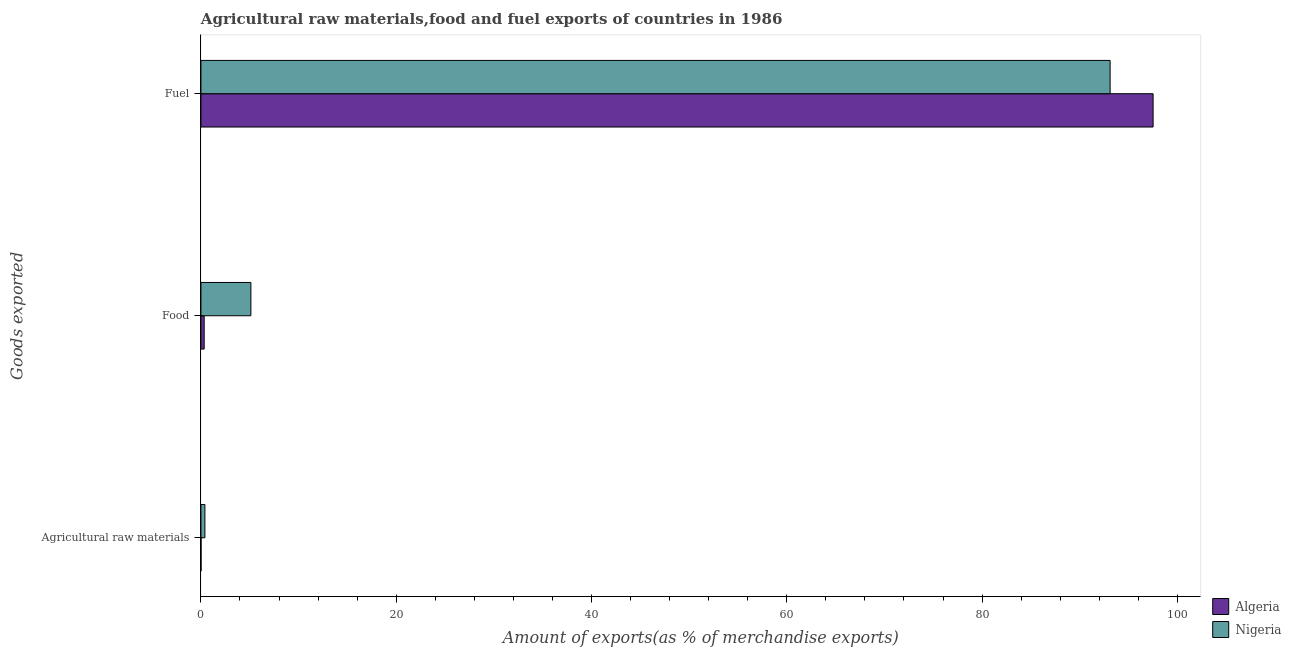How many groups of bars are there?
Provide a succinct answer. 3. Are the number of bars on each tick of the Y-axis equal?
Keep it short and to the point. Yes. What is the label of the 2nd group of bars from the top?
Offer a very short reply. Food. What is the percentage of fuel exports in Algeria?
Give a very brief answer. 97.51. Across all countries, what is the maximum percentage of food exports?
Provide a short and direct response. 5.12. Across all countries, what is the minimum percentage of food exports?
Give a very brief answer. 0.34. In which country was the percentage of raw materials exports maximum?
Your answer should be compact. Nigeria. In which country was the percentage of raw materials exports minimum?
Provide a short and direct response. Algeria. What is the total percentage of raw materials exports in the graph?
Ensure brevity in your answer.  0.42. What is the difference between the percentage of food exports in Algeria and that in Nigeria?
Keep it short and to the point. -4.78. What is the difference between the percentage of fuel exports in Nigeria and the percentage of food exports in Algeria?
Your answer should be compact. 92.78. What is the average percentage of fuel exports per country?
Ensure brevity in your answer.  95.31. What is the difference between the percentage of raw materials exports and percentage of fuel exports in Algeria?
Give a very brief answer. -97.5. What is the ratio of the percentage of raw materials exports in Algeria to that in Nigeria?
Your answer should be very brief. 0.03. Is the percentage of fuel exports in Algeria less than that in Nigeria?
Give a very brief answer. No. Is the difference between the percentage of fuel exports in Algeria and Nigeria greater than the difference between the percentage of food exports in Algeria and Nigeria?
Offer a terse response. Yes. What is the difference between the highest and the second highest percentage of fuel exports?
Offer a very short reply. 4.4. What is the difference between the highest and the lowest percentage of raw materials exports?
Offer a very short reply. 0.4. In how many countries, is the percentage of raw materials exports greater than the average percentage of raw materials exports taken over all countries?
Ensure brevity in your answer.  1. What does the 1st bar from the top in Agricultural raw materials represents?
Ensure brevity in your answer.  Nigeria. What does the 1st bar from the bottom in Food represents?
Give a very brief answer. Algeria. Are all the bars in the graph horizontal?
Make the answer very short. Yes. Does the graph contain any zero values?
Ensure brevity in your answer.  No. Where does the legend appear in the graph?
Provide a succinct answer. Bottom right. How many legend labels are there?
Provide a short and direct response. 2. What is the title of the graph?
Your answer should be very brief. Agricultural raw materials,food and fuel exports of countries in 1986. What is the label or title of the X-axis?
Ensure brevity in your answer.  Amount of exports(as % of merchandise exports). What is the label or title of the Y-axis?
Provide a succinct answer. Goods exported. What is the Amount of exports(as % of merchandise exports) in Algeria in Agricultural raw materials?
Your response must be concise. 0.01. What is the Amount of exports(as % of merchandise exports) of Nigeria in Agricultural raw materials?
Give a very brief answer. 0.41. What is the Amount of exports(as % of merchandise exports) in Algeria in Food?
Offer a terse response. 0.34. What is the Amount of exports(as % of merchandise exports) of Nigeria in Food?
Make the answer very short. 5.12. What is the Amount of exports(as % of merchandise exports) of Algeria in Fuel?
Provide a succinct answer. 97.51. What is the Amount of exports(as % of merchandise exports) in Nigeria in Fuel?
Provide a succinct answer. 93.11. Across all Goods exported, what is the maximum Amount of exports(as % of merchandise exports) in Algeria?
Provide a succinct answer. 97.51. Across all Goods exported, what is the maximum Amount of exports(as % of merchandise exports) in Nigeria?
Your response must be concise. 93.11. Across all Goods exported, what is the minimum Amount of exports(as % of merchandise exports) of Algeria?
Ensure brevity in your answer.  0.01. Across all Goods exported, what is the minimum Amount of exports(as % of merchandise exports) in Nigeria?
Your response must be concise. 0.41. What is the total Amount of exports(as % of merchandise exports) in Algeria in the graph?
Your response must be concise. 97.86. What is the total Amount of exports(as % of merchandise exports) of Nigeria in the graph?
Your response must be concise. 98.64. What is the difference between the Amount of exports(as % of merchandise exports) of Algeria in Agricultural raw materials and that in Food?
Your response must be concise. -0.32. What is the difference between the Amount of exports(as % of merchandise exports) of Nigeria in Agricultural raw materials and that in Food?
Provide a succinct answer. -4.71. What is the difference between the Amount of exports(as % of merchandise exports) in Algeria in Agricultural raw materials and that in Fuel?
Provide a succinct answer. -97.5. What is the difference between the Amount of exports(as % of merchandise exports) of Nigeria in Agricultural raw materials and that in Fuel?
Your response must be concise. -92.7. What is the difference between the Amount of exports(as % of merchandise exports) in Algeria in Food and that in Fuel?
Provide a short and direct response. -97.18. What is the difference between the Amount of exports(as % of merchandise exports) in Nigeria in Food and that in Fuel?
Ensure brevity in your answer.  -87.99. What is the difference between the Amount of exports(as % of merchandise exports) in Algeria in Agricultural raw materials and the Amount of exports(as % of merchandise exports) in Nigeria in Food?
Your answer should be very brief. -5.11. What is the difference between the Amount of exports(as % of merchandise exports) in Algeria in Agricultural raw materials and the Amount of exports(as % of merchandise exports) in Nigeria in Fuel?
Your answer should be compact. -93.1. What is the difference between the Amount of exports(as % of merchandise exports) in Algeria in Food and the Amount of exports(as % of merchandise exports) in Nigeria in Fuel?
Offer a terse response. -92.78. What is the average Amount of exports(as % of merchandise exports) in Algeria per Goods exported?
Ensure brevity in your answer.  32.62. What is the average Amount of exports(as % of merchandise exports) in Nigeria per Goods exported?
Make the answer very short. 32.88. What is the difference between the Amount of exports(as % of merchandise exports) of Algeria and Amount of exports(as % of merchandise exports) of Nigeria in Agricultural raw materials?
Offer a terse response. -0.4. What is the difference between the Amount of exports(as % of merchandise exports) in Algeria and Amount of exports(as % of merchandise exports) in Nigeria in Food?
Ensure brevity in your answer.  -4.78. What is the difference between the Amount of exports(as % of merchandise exports) in Algeria and Amount of exports(as % of merchandise exports) in Nigeria in Fuel?
Your response must be concise. 4.4. What is the ratio of the Amount of exports(as % of merchandise exports) of Algeria in Agricultural raw materials to that in Food?
Offer a very short reply. 0.03. What is the ratio of the Amount of exports(as % of merchandise exports) of Nigeria in Agricultural raw materials to that in Fuel?
Your answer should be very brief. 0. What is the ratio of the Amount of exports(as % of merchandise exports) in Algeria in Food to that in Fuel?
Give a very brief answer. 0. What is the ratio of the Amount of exports(as % of merchandise exports) in Nigeria in Food to that in Fuel?
Your answer should be compact. 0.06. What is the difference between the highest and the second highest Amount of exports(as % of merchandise exports) of Algeria?
Your answer should be very brief. 97.18. What is the difference between the highest and the second highest Amount of exports(as % of merchandise exports) of Nigeria?
Ensure brevity in your answer.  87.99. What is the difference between the highest and the lowest Amount of exports(as % of merchandise exports) of Algeria?
Ensure brevity in your answer.  97.5. What is the difference between the highest and the lowest Amount of exports(as % of merchandise exports) of Nigeria?
Your answer should be very brief. 92.7. 